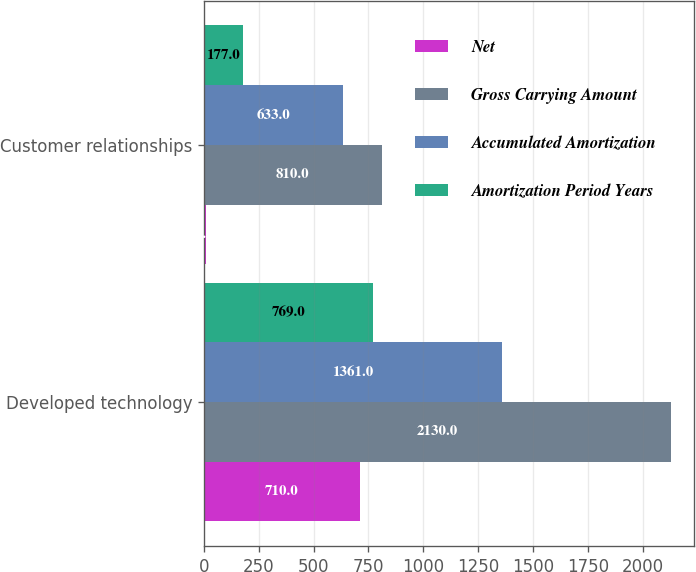Convert chart to OTSL. <chart><loc_0><loc_0><loc_500><loc_500><stacked_bar_chart><ecel><fcel>Developed technology<fcel>Customer relationships<nl><fcel>Net<fcel>710<fcel>8<nl><fcel>Gross Carrying Amount<fcel>2130<fcel>810<nl><fcel>Accumulated Amortization<fcel>1361<fcel>633<nl><fcel>Amortization Period Years<fcel>769<fcel>177<nl></chart> 